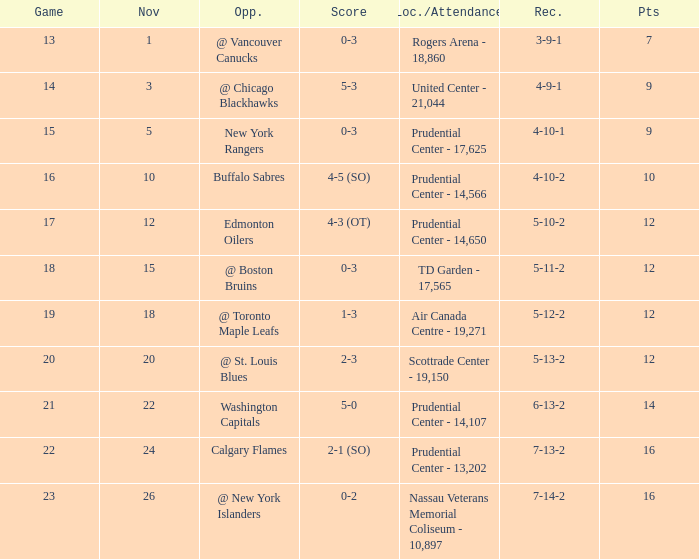What is the record that had a score of 5-3? 4-9-1. 